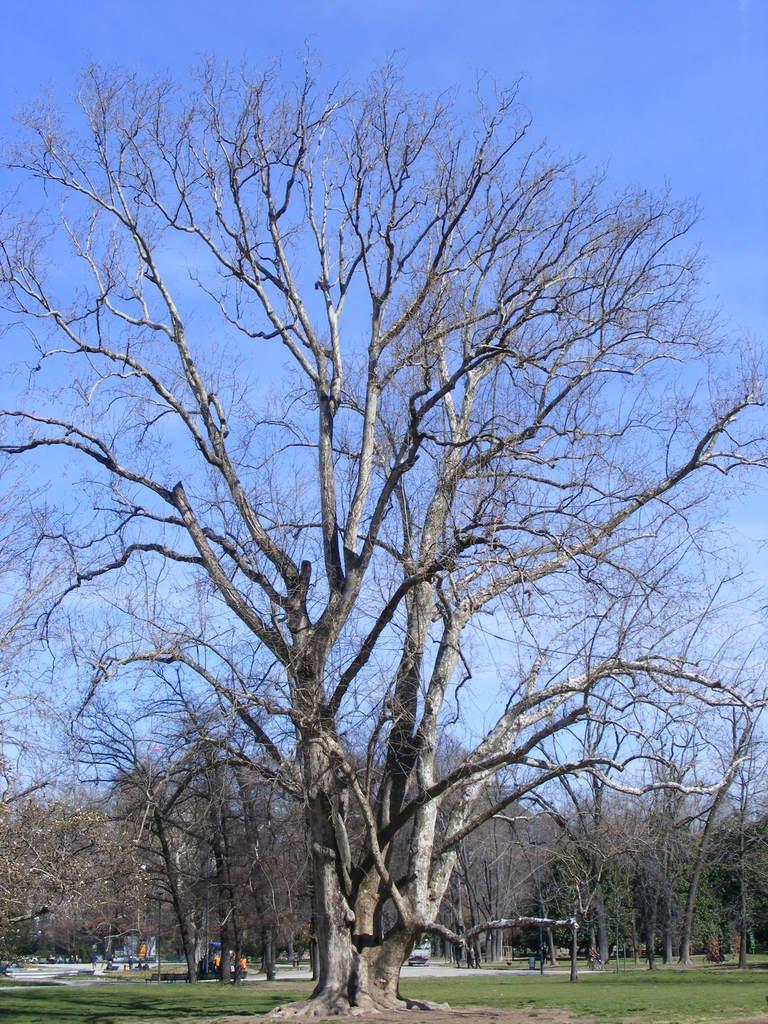What type of vegetation can be seen in the image? There is a group of trees with dried branches in the image. What else can be seen on the ground in the image? There is grass visible in the image. What is visible in the background of the image? The sky is visible in the image. How would you describe the sky in the image? The sky appears to be cloudy. What type of meat is hanging from the trees in the image? There is no meat present in the image; it features a group of trees with dried branches. What type of flowers can be seen growing among the grass in the image? There are no flowers mentioned or visible in the image; it only features grass and trees with dried branches. 